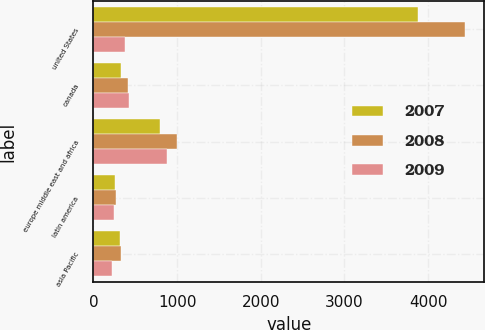<chart> <loc_0><loc_0><loc_500><loc_500><stacked_bar_chart><ecel><fcel>united States<fcel>canada<fcel>europe middle east and africa<fcel>latin america<fcel>asia Pacific<nl><fcel>2007<fcel>3881.4<fcel>326.5<fcel>795.1<fcel>262.9<fcel>311.7<nl><fcel>2008<fcel>4447.2<fcel>413.4<fcel>1000.1<fcel>275.4<fcel>334.5<nl><fcel>2009<fcel>373.95<fcel>425.7<fcel>880.7<fcel>250.2<fcel>226.4<nl></chart> 